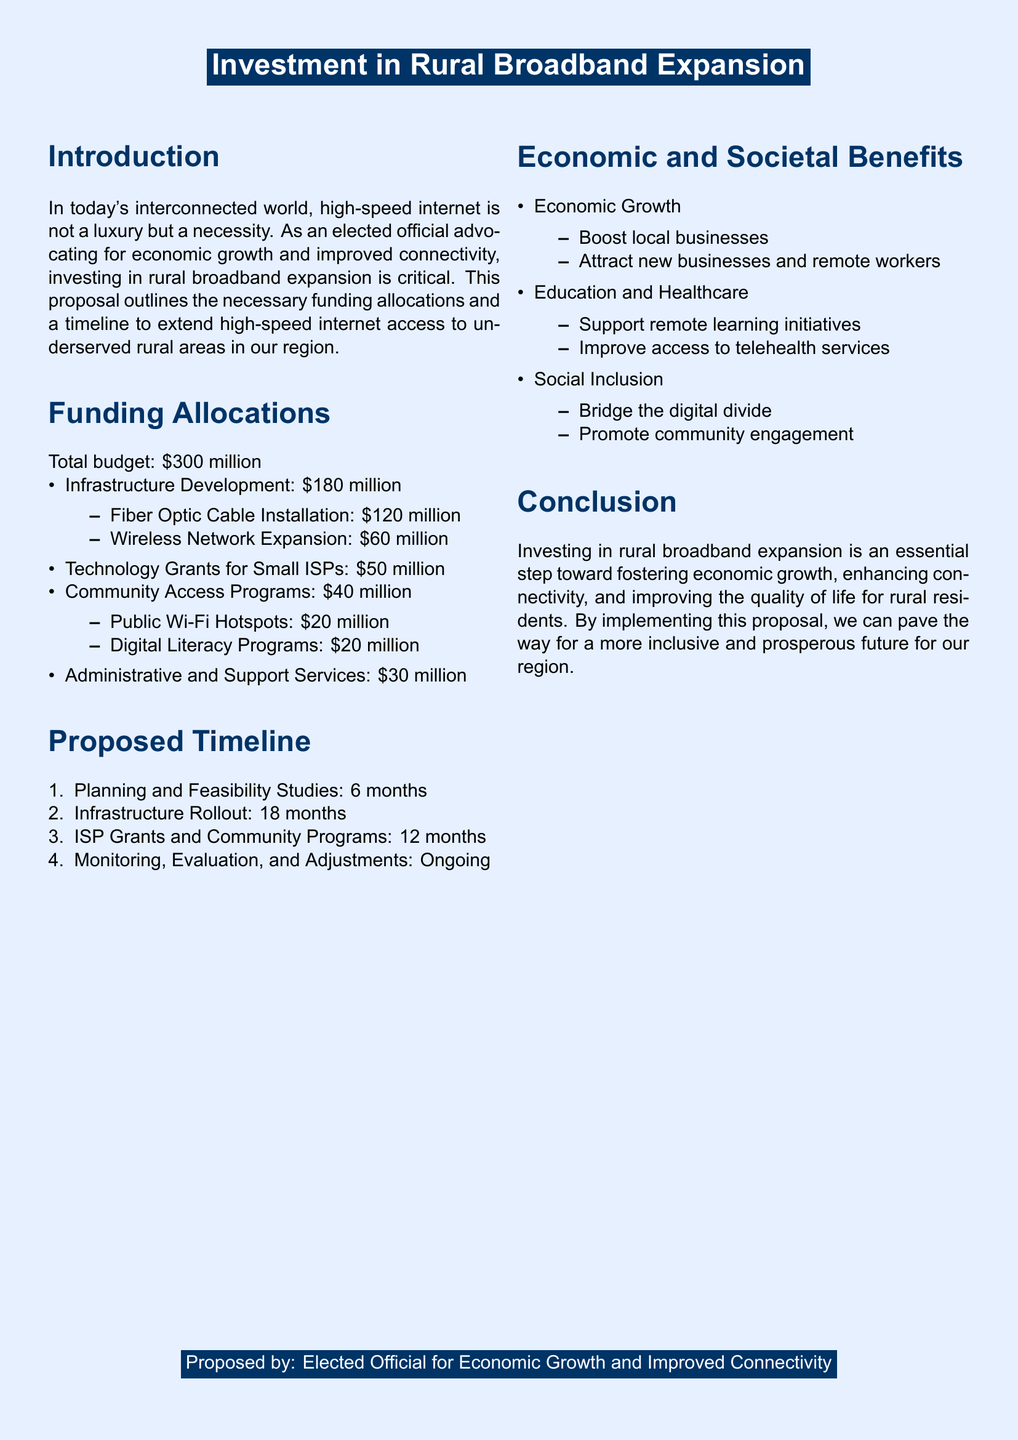What is the total budget for the rural broadband expansion? The total budget is explicitly mentioned in the document as $300 million.
Answer: $300 million How much is allocated for Fiber Optic Cable Installation? This amount is clearly outlined under Funding Allocations in the document as $120 million.
Answer: $120 million What is the duration for Planning and Feasibility Studies? The document states that this phase will take 6 months.
Answer: 6 months What percentage of the budget is allocated for Infrastructure Development? Infrastructure Development funding is $180 million out of a total budget of $300 million, which is 60%.
Answer: 60% How much funding is designated for Community Access Programs? The document specifies that Community Access Programs will receive $40 million.
Answer: $40 million What are the two components under Technology Grants for Small ISPs? The proposal includes technology grants, which are part of the funding but does not specify the components; thus, reasoning is required.
Answer: $50 million (specifically grants, no further components listed) What ongoing process is mentioned in the Proposed Timeline? The document lists "Monitoring, Evaluation, and Adjustments" as an ongoing process.
Answer: Monitoring, Evaluation, and Adjustments Who proposed the investment in rural broadband expansion? The document mentions that it was proposed by the "Elected Official for Economic Growth and Improved Connectivity."
Answer: Elected Official for Economic Growth and Improved Connectivity 